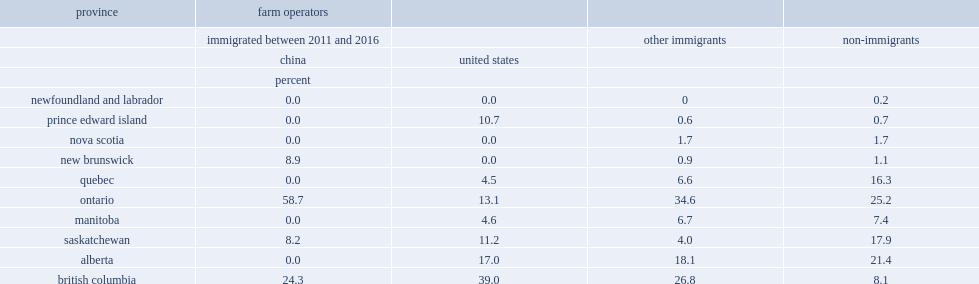What is the most frequently reported provincial destination for farm operators who came from the united states between 2011 and 2016? British columbia. Which kind of farm operator has a higher proportion of choosing british columbia as their provincial destination? United states. 